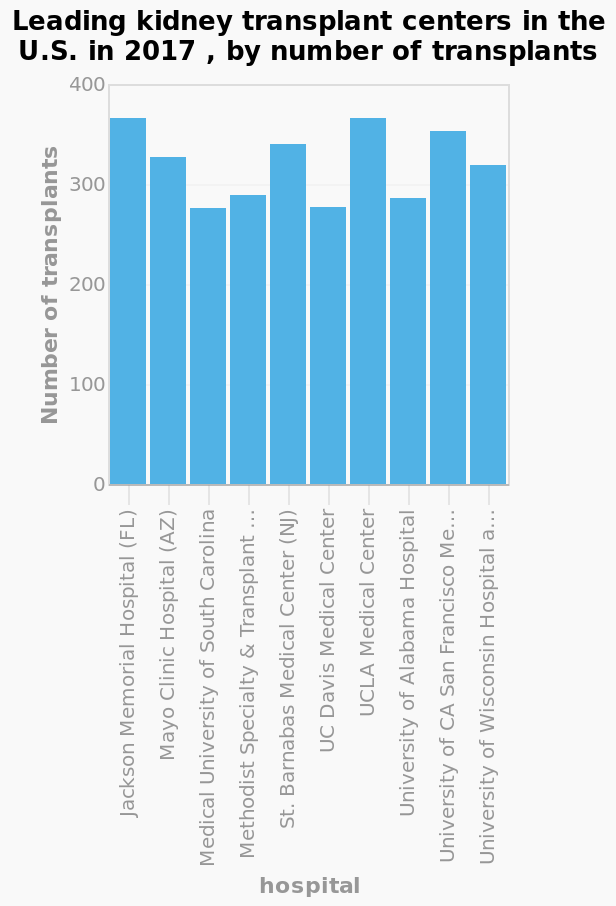<image>
What is the range of the y-axis on the bar diagram?  The range is from 0 to 400. What is the range of the number of transplants between hospitals?  The range of the number of transplants between hospitals is around 100. Which hospital had the lowest number of kidney transplants in 2017?  Jackson Memorial Hospital (FL) What is the scale used for measuring the countries on the y-axis? Categorical scale Offer a thorough analysis of the image. The difference between the hospitals with the highest and lowest number of transplants is around 100. How many kidney transplants were performed by Jackson Memorial Hospital (FL) in 2017? The number of kidney transplants performed by Jackson Memorial Hospital (FL) in 2017 is not specified in the given description. 